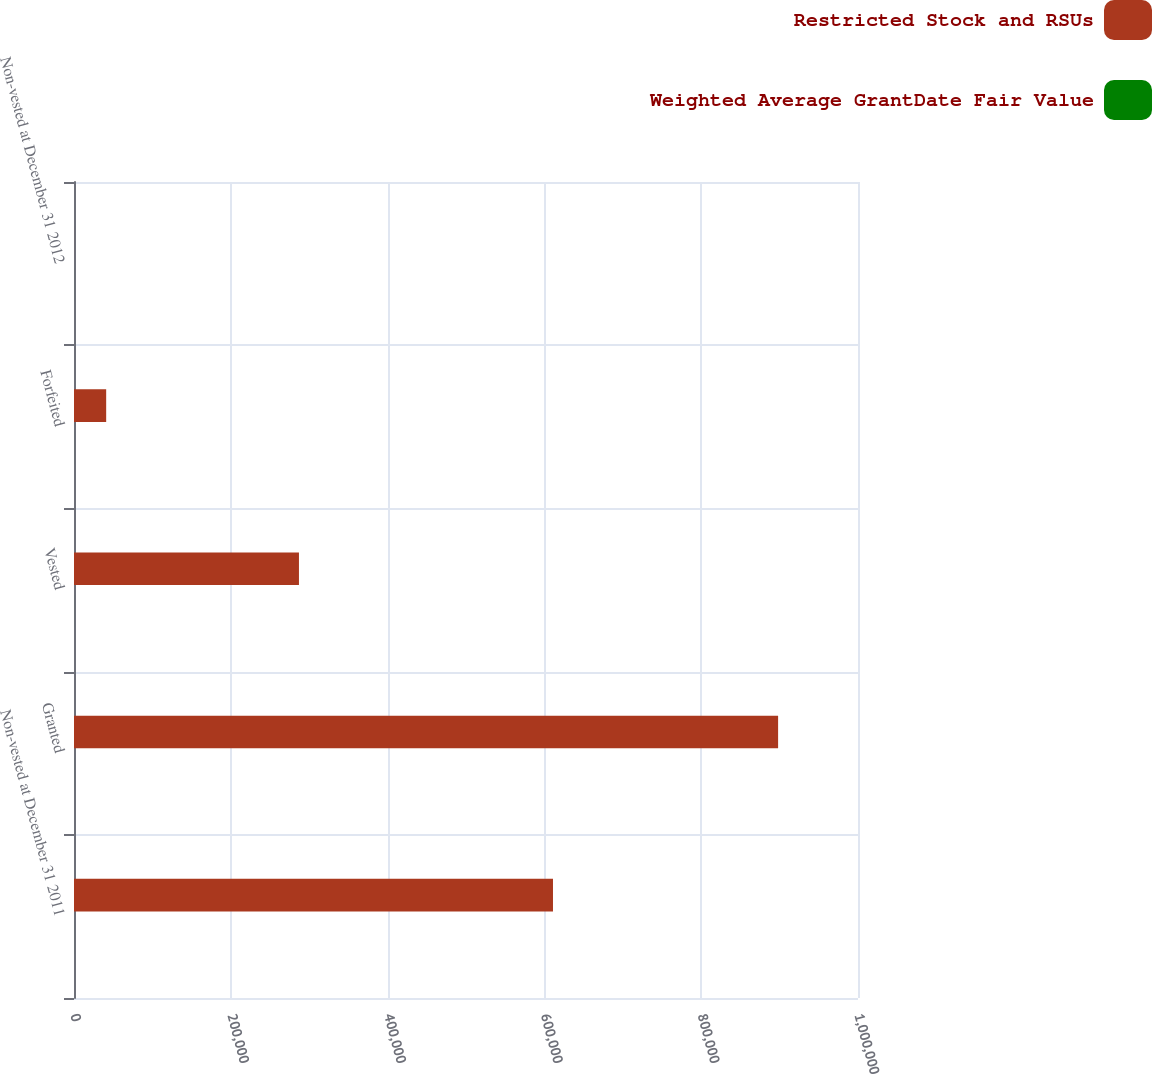Convert chart to OTSL. <chart><loc_0><loc_0><loc_500><loc_500><stacked_bar_chart><ecel><fcel>Non-vested at December 31 2011<fcel>Granted<fcel>Vested<fcel>Forfeited<fcel>Non-vested at December 31 2012<nl><fcel>Restricted Stock and RSUs<fcel>610951<fcel>898093<fcel>286931<fcel>41038<fcel>30.08<nl><fcel>Weighted Average GrantDate Fair Value<fcel>28.85<fcel>30.08<fcel>28.91<fcel>27.51<fcel>29.89<nl></chart> 